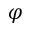<formula> <loc_0><loc_0><loc_500><loc_500>\varphi</formula> 